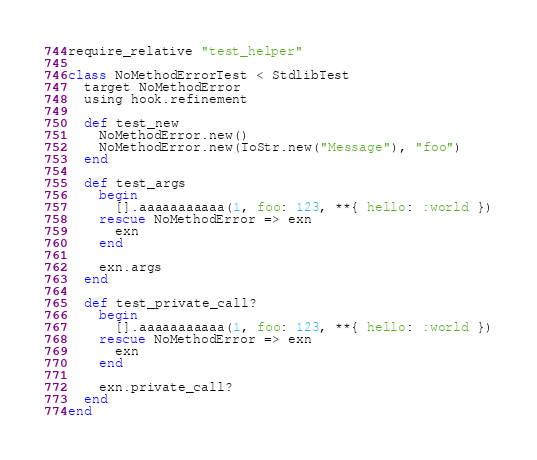Convert code to text. <code><loc_0><loc_0><loc_500><loc_500><_Ruby_>require_relative "test_helper"

class NoMethodErrorTest < StdlibTest
  target NoMethodError
  using hook.refinement

  def test_new
    NoMethodError.new()
    NoMethodError.new(ToStr.new("Message"), "foo")
  end

  def test_args
    begin
      [].aaaaaaaaaaa(1, foo: 123, **{ hello: :world })
    rescue NoMethodError => exn
      exn
    end

    exn.args
  end

  def test_private_call?
    begin
      [].aaaaaaaaaaa(1, foo: 123, **{ hello: :world })
    rescue NoMethodError => exn
      exn
    end

    exn.private_call?
  end
end
</code> 